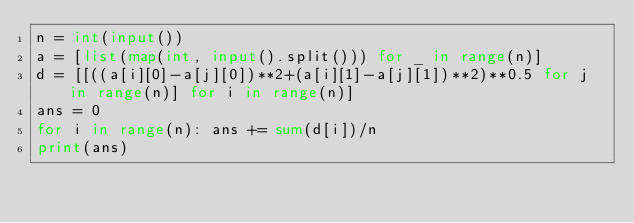<code> <loc_0><loc_0><loc_500><loc_500><_Python_>n = int(input())
a = [list(map(int, input().split())) for _ in range(n)]
d = [[((a[i][0]-a[j][0])**2+(a[i][1]-a[j][1])**2)**0.5 for j in range(n)] for i in range(n)]
ans = 0
for i in range(n): ans += sum(d[i])/n
print(ans)</code> 